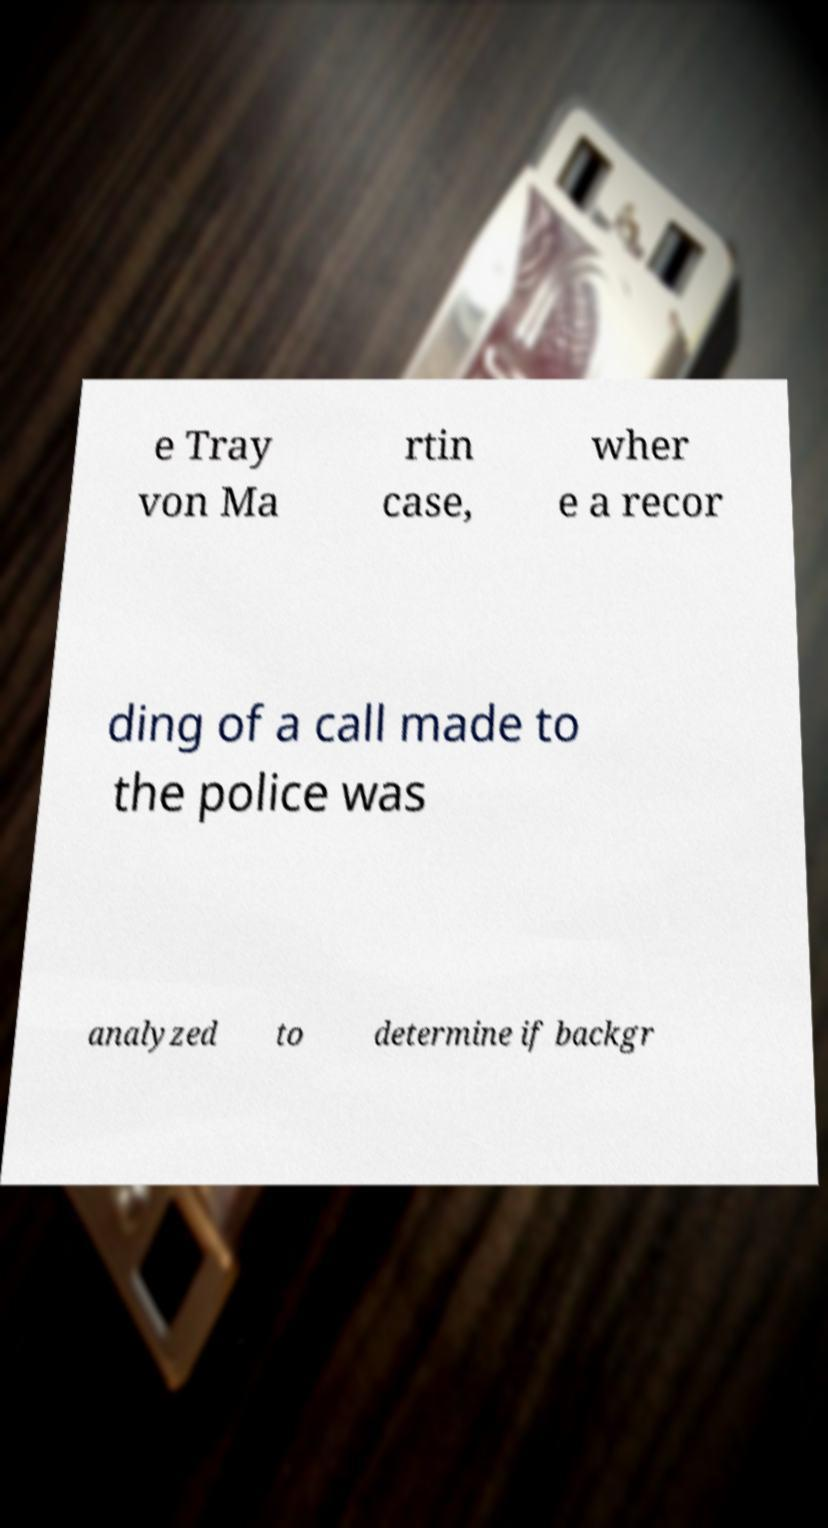Please read and relay the text visible in this image. What does it say? e Tray von Ma rtin case, wher e a recor ding of a call made to the police was analyzed to determine if backgr 